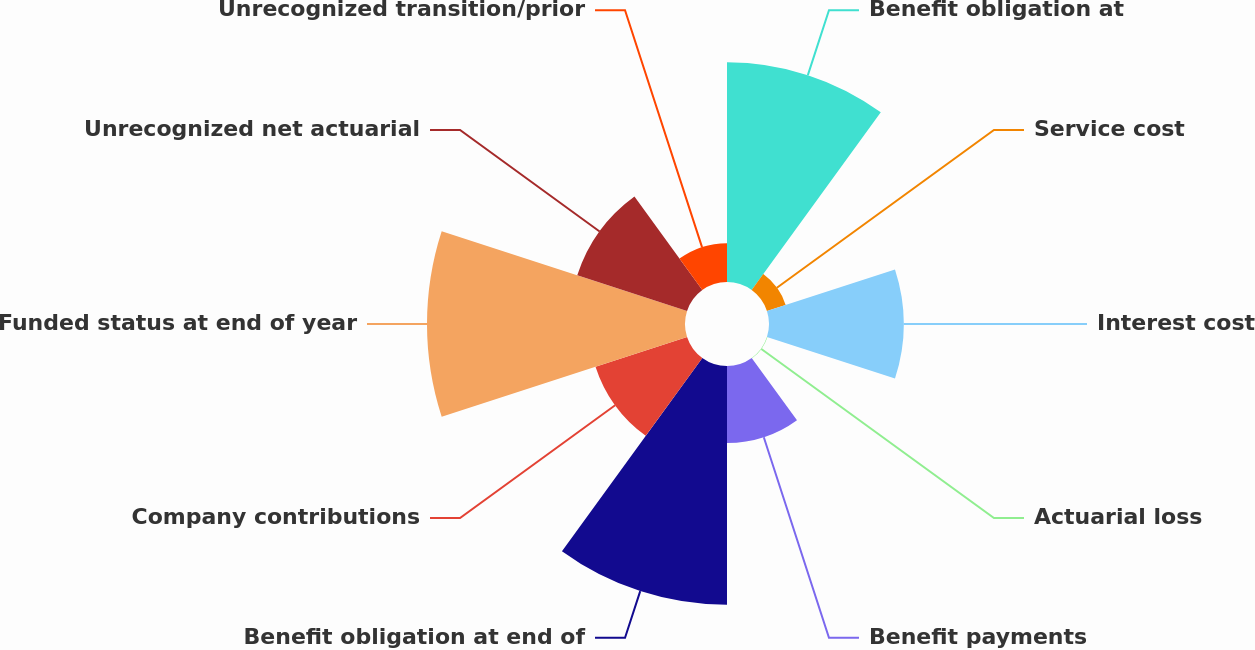Convert chart to OTSL. <chart><loc_0><loc_0><loc_500><loc_500><pie_chart><fcel>Benefit obligation at<fcel>Service cost<fcel>Interest cost<fcel>Actuarial loss<fcel>Benefit payments<fcel>Benefit obligation at end of<fcel>Company contributions<fcel>Funded status at end of year<fcel>Unrecognized net actuarial<fcel>Unrecognized transition/prior<nl><fcel>18.32%<fcel>1.64%<fcel>11.23%<fcel>0.04%<fcel>6.43%<fcel>19.92%<fcel>8.03%<fcel>21.52%<fcel>9.63%<fcel>3.24%<nl></chart> 